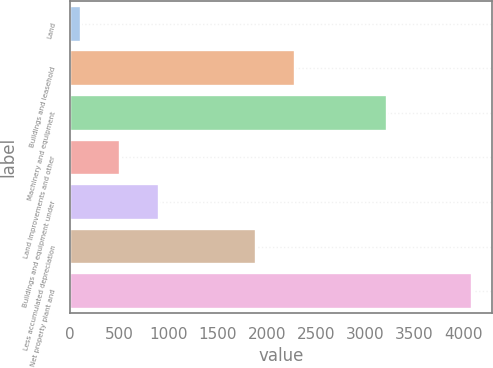Convert chart to OTSL. <chart><loc_0><loc_0><loc_500><loc_500><bar_chart><fcel>Land<fcel>Buildings and leasehold<fcel>Machinery and equipment<fcel>Land improvements and other<fcel>Buildings and equipment under<fcel>Less accumulated depreciation<fcel>Net property plant and<nl><fcel>114<fcel>2282.1<fcel>3218<fcel>511.1<fcel>908.2<fcel>1885<fcel>4085<nl></chart> 